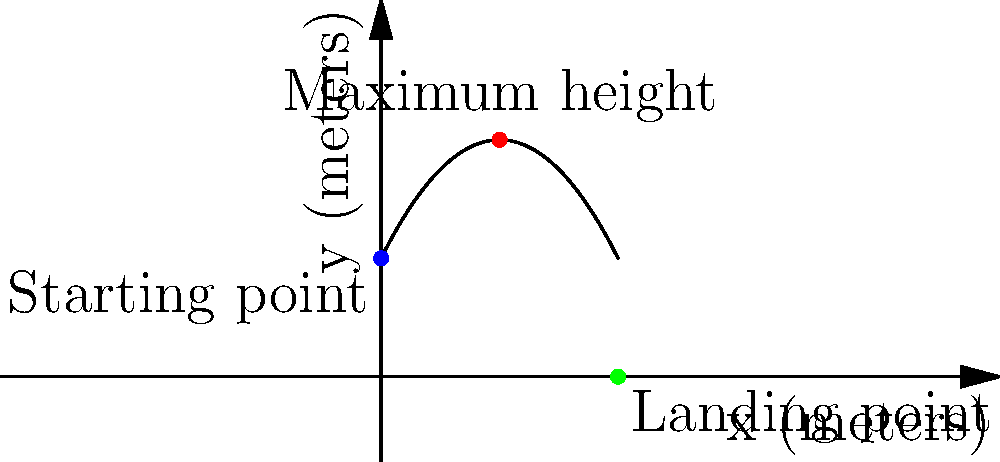During a crucial match, Damir Buljević executed his famous "Buljević Blast" serve. The trajectory of the volleyball can be modeled by the parabolic function $f(x) = -0.2x^2 + 2x + 5$, where $x$ is the horizontal distance from the serving position in meters, and $f(x)$ is the height of the ball in meters. What is the maximum height reached by the volleyball during this serve? To find the maximum height of the volleyball's trajectory, we need to follow these steps:

1) The maximum height occurs at the vertex of the parabola. For a quadratic function in the form $f(x) = ax^2 + bx + c$, the x-coordinate of the vertex is given by $x = -\frac{b}{2a}$.

2) In our function $f(x) = -0.2x^2 + 2x + 5$, we have:
   $a = -0.2$
   $b = 2$
   $c = 5$

3) Calculate the x-coordinate of the vertex:
   $x = -\frac{b}{2a} = -\frac{2}{2(-0.2)} = -\frac{2}{-0.4} = 5$ meters

4) To find the maximum height, we need to calculate $f(5)$:
   $f(5) = -0.2(5)^2 + 2(5) + 5$
         $= -0.2(25) + 10 + 5$
         $= -5 + 10 + 5$
         $= 10$ meters

Therefore, the maximum height reached by the volleyball during Damir Buljević's serve is 10 meters.
Answer: 10 meters 